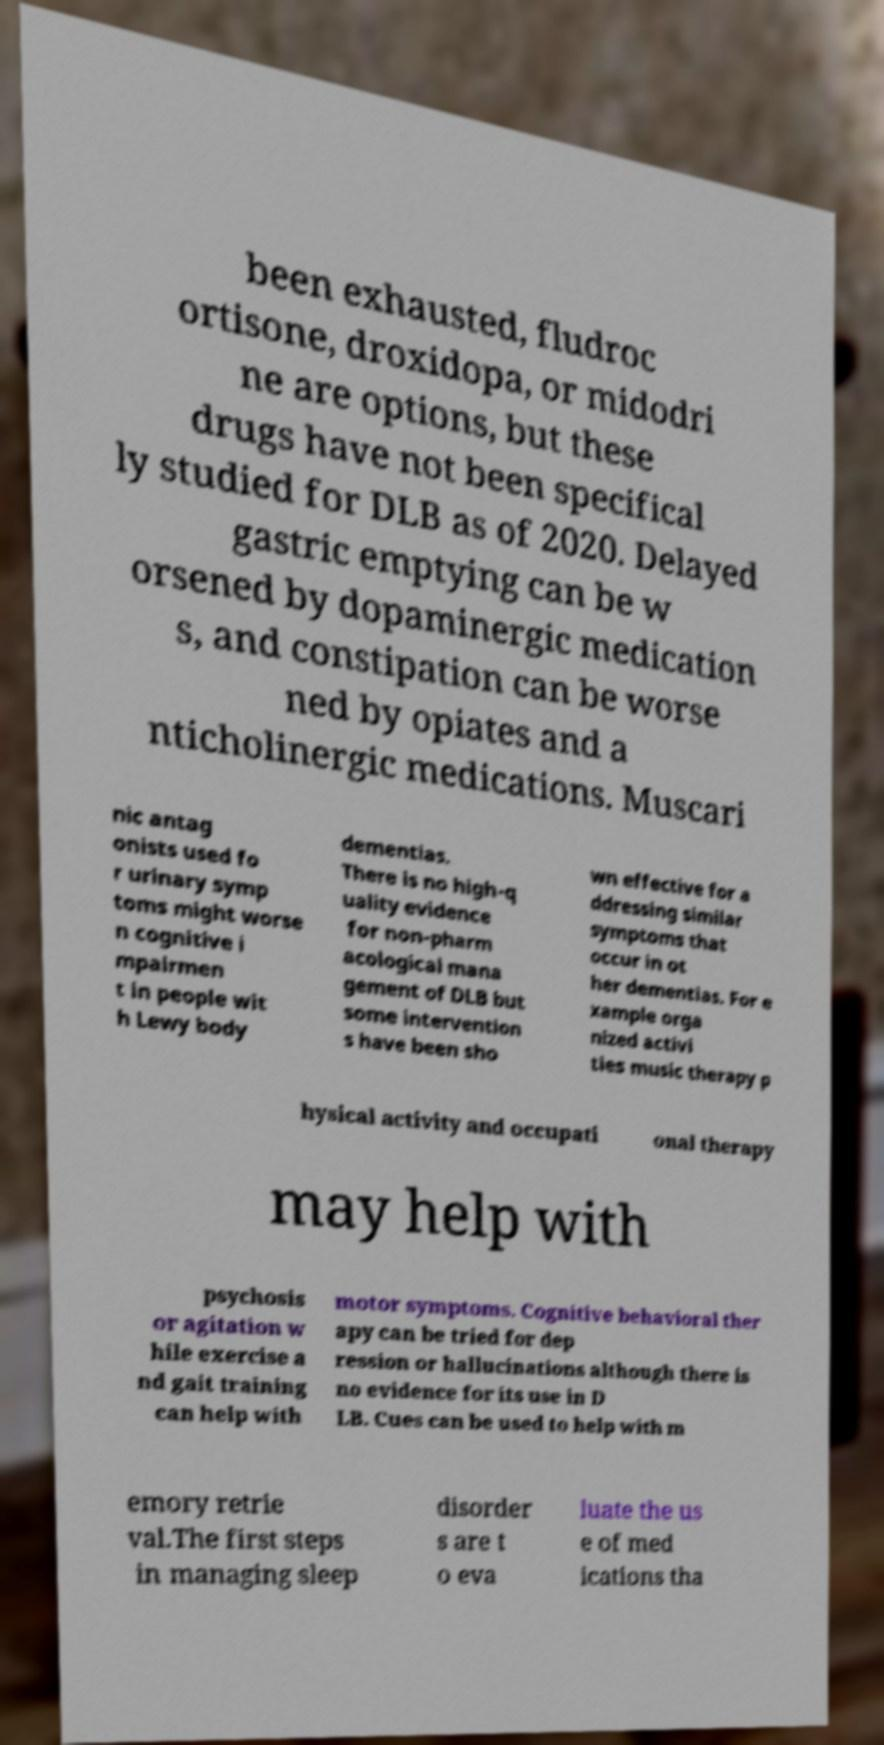What messages or text are displayed in this image? I need them in a readable, typed format. been exhausted, fludroc ortisone, droxidopa, or midodri ne are options, but these drugs have not been specifical ly studied for DLB as of 2020. Delayed gastric emptying can be w orsened by dopaminergic medication s, and constipation can be worse ned by opiates and a nticholinergic medications. Muscari nic antag onists used fo r urinary symp toms might worse n cognitive i mpairmen t in people wit h Lewy body dementias. There is no high-q uality evidence for non-pharm acological mana gement of DLB but some intervention s have been sho wn effective for a ddressing similar symptoms that occur in ot her dementias. For e xample orga nized activi ties music therapy p hysical activity and occupati onal therapy may help with psychosis or agitation w hile exercise a nd gait training can help with motor symptoms. Cognitive behavioral ther apy can be tried for dep ression or hallucinations although there is no evidence for its use in D LB. Cues can be used to help with m emory retrie val.The first steps in managing sleep disorder s are t o eva luate the us e of med ications tha 